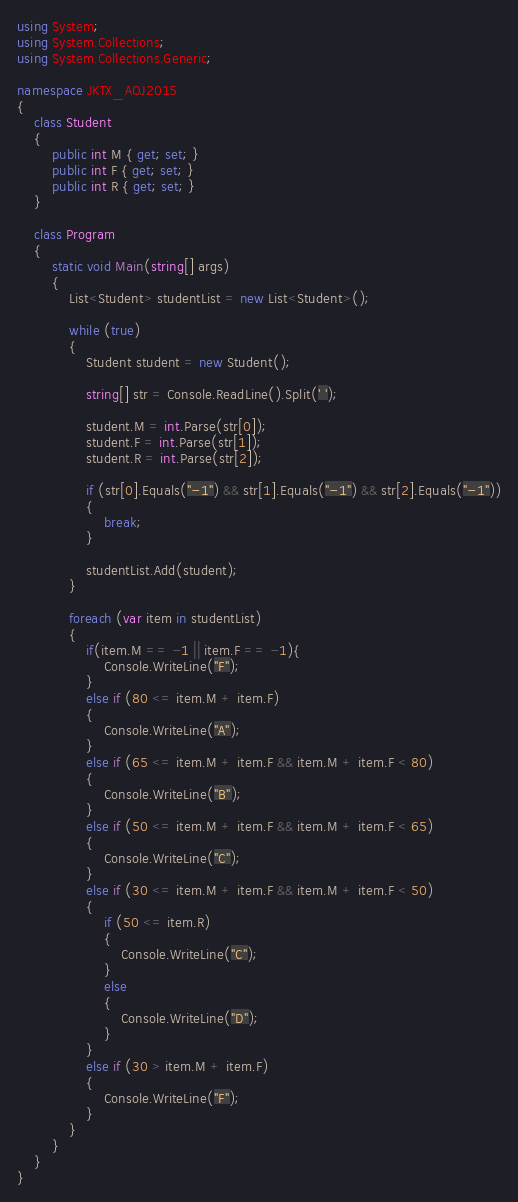<code> <loc_0><loc_0><loc_500><loc_500><_C#_>using System;
using System.Collections;
using System.Collections.Generic;

namespace JKTX_AOJ2015
{
    class Student
    {
        public int M { get; set; }
        public int F { get; set; }
        public int R { get; set; }
    }

    class Program
    {
        static void Main(string[] args)
        {
            List<Student> studentList = new List<Student>();

            while (true)
            {
                Student student = new Student();

                string[] str = Console.ReadLine().Split(' ');

                student.M = int.Parse(str[0]);
                student.F = int.Parse(str[1]);
                student.R = int.Parse(str[2]);

                if (str[0].Equals("-1") && str[1].Equals("-1") && str[2].Equals("-1"))
                {
                    break;
                }

                studentList.Add(student);
            }

            foreach (var item in studentList)
            {
                if(item.M == -1 || item.F == -1){
                    Console.WriteLine("F");
                }
                else if (80 <= item.M + item.F)
                {
                    Console.WriteLine("A");
                }
                else if (65 <= item.M + item.F && item.M + item.F < 80)
                {
                    Console.WriteLine("B");
                }
                else if (50 <= item.M + item.F && item.M + item.F < 65)
                {
                    Console.WriteLine("C");
                }
                else if (30 <= item.M + item.F && item.M + item.F < 50)
                {
                    if (50 <= item.R)
                    {
                        Console.WriteLine("C");
                    }
                    else
                    {
                        Console.WriteLine("D");
                    }
                }
                else if (30 > item.M + item.F)
                {
                    Console.WriteLine("F");
                }
            }
        }
    }
}</code> 